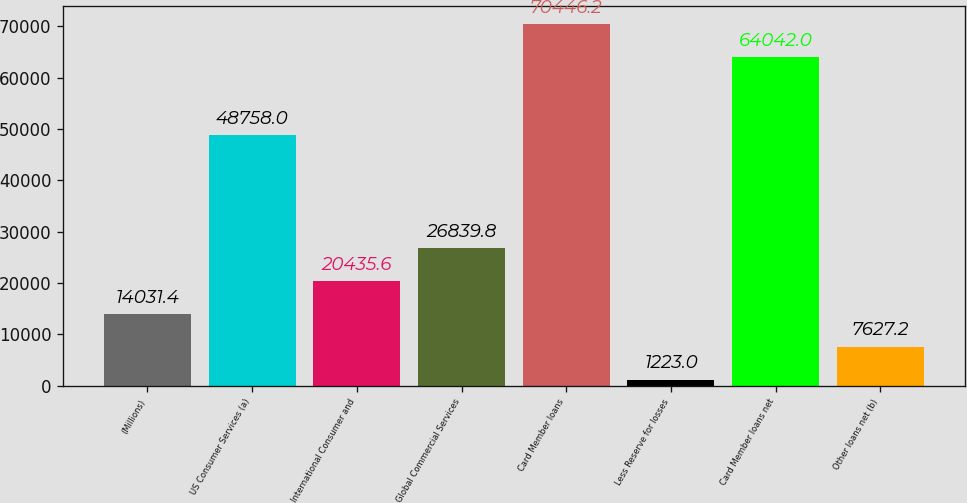<chart> <loc_0><loc_0><loc_500><loc_500><bar_chart><fcel>(Millions)<fcel>US Consumer Services (a)<fcel>International Consumer and<fcel>Global Commercial Services<fcel>Card Member loans<fcel>Less Reserve for losses<fcel>Card Member loans net<fcel>Other loans net (b)<nl><fcel>14031.4<fcel>48758<fcel>20435.6<fcel>26839.8<fcel>70446.2<fcel>1223<fcel>64042<fcel>7627.2<nl></chart> 